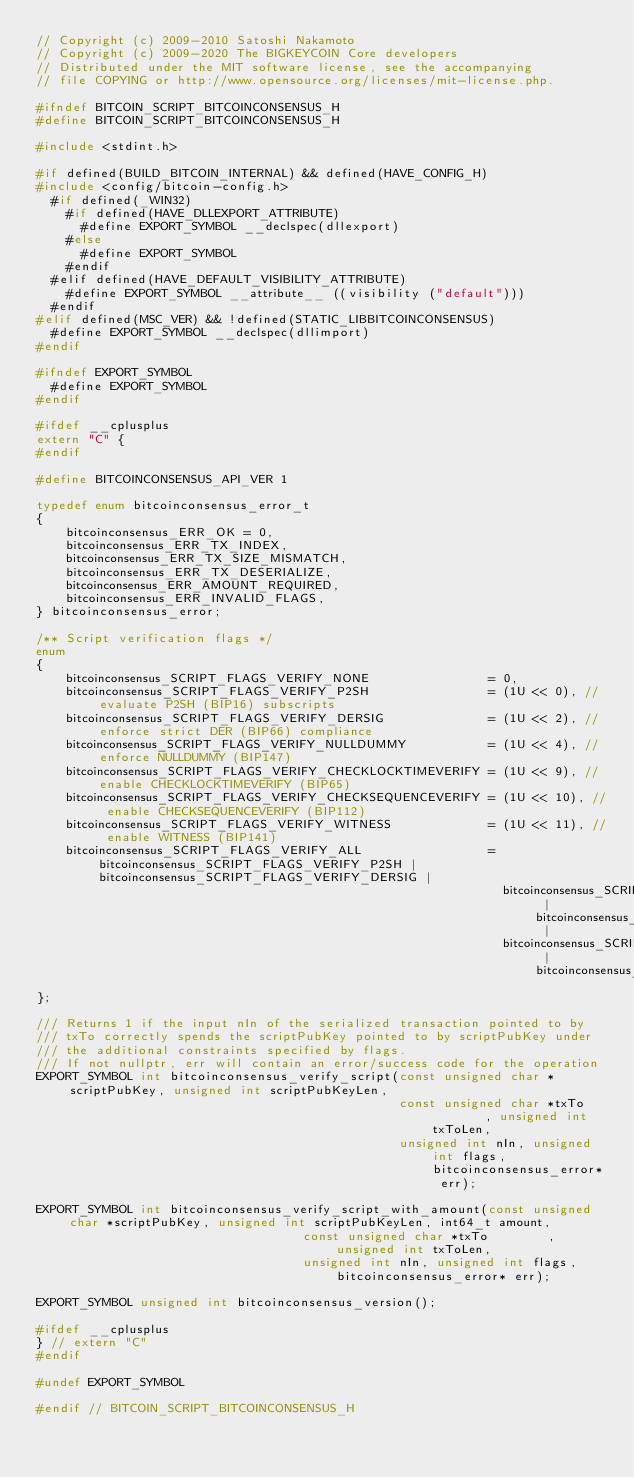<code> <loc_0><loc_0><loc_500><loc_500><_C_>// Copyright (c) 2009-2010 Satoshi Nakamoto
// Copyright (c) 2009-2020 The BIGKEYCOIN Core developers
// Distributed under the MIT software license, see the accompanying
// file COPYING or http://www.opensource.org/licenses/mit-license.php.

#ifndef BITCOIN_SCRIPT_BITCOINCONSENSUS_H
#define BITCOIN_SCRIPT_BITCOINCONSENSUS_H

#include <stdint.h>

#if defined(BUILD_BITCOIN_INTERNAL) && defined(HAVE_CONFIG_H)
#include <config/bitcoin-config.h>
  #if defined(_WIN32)
    #if defined(HAVE_DLLEXPORT_ATTRIBUTE)
      #define EXPORT_SYMBOL __declspec(dllexport)
    #else
      #define EXPORT_SYMBOL
    #endif
  #elif defined(HAVE_DEFAULT_VISIBILITY_ATTRIBUTE)
    #define EXPORT_SYMBOL __attribute__ ((visibility ("default")))
  #endif
#elif defined(MSC_VER) && !defined(STATIC_LIBBITCOINCONSENSUS)
  #define EXPORT_SYMBOL __declspec(dllimport)
#endif

#ifndef EXPORT_SYMBOL
  #define EXPORT_SYMBOL
#endif

#ifdef __cplusplus
extern "C" {
#endif

#define BITCOINCONSENSUS_API_VER 1

typedef enum bitcoinconsensus_error_t
{
    bitcoinconsensus_ERR_OK = 0,
    bitcoinconsensus_ERR_TX_INDEX,
    bitcoinconsensus_ERR_TX_SIZE_MISMATCH,
    bitcoinconsensus_ERR_TX_DESERIALIZE,
    bitcoinconsensus_ERR_AMOUNT_REQUIRED,
    bitcoinconsensus_ERR_INVALID_FLAGS,
} bitcoinconsensus_error;

/** Script verification flags */
enum
{
    bitcoinconsensus_SCRIPT_FLAGS_VERIFY_NONE                = 0,
    bitcoinconsensus_SCRIPT_FLAGS_VERIFY_P2SH                = (1U << 0), // evaluate P2SH (BIP16) subscripts
    bitcoinconsensus_SCRIPT_FLAGS_VERIFY_DERSIG              = (1U << 2), // enforce strict DER (BIP66) compliance
    bitcoinconsensus_SCRIPT_FLAGS_VERIFY_NULLDUMMY           = (1U << 4), // enforce NULLDUMMY (BIP147)
    bitcoinconsensus_SCRIPT_FLAGS_VERIFY_CHECKLOCKTIMEVERIFY = (1U << 9), // enable CHECKLOCKTIMEVERIFY (BIP65)
    bitcoinconsensus_SCRIPT_FLAGS_VERIFY_CHECKSEQUENCEVERIFY = (1U << 10), // enable CHECKSEQUENCEVERIFY (BIP112)
    bitcoinconsensus_SCRIPT_FLAGS_VERIFY_WITNESS             = (1U << 11), // enable WITNESS (BIP141)
    bitcoinconsensus_SCRIPT_FLAGS_VERIFY_ALL                 = bitcoinconsensus_SCRIPT_FLAGS_VERIFY_P2SH | bitcoinconsensus_SCRIPT_FLAGS_VERIFY_DERSIG |
                                                               bitcoinconsensus_SCRIPT_FLAGS_VERIFY_NULLDUMMY | bitcoinconsensus_SCRIPT_FLAGS_VERIFY_CHECKLOCKTIMEVERIFY |
                                                               bitcoinconsensus_SCRIPT_FLAGS_VERIFY_CHECKSEQUENCEVERIFY | bitcoinconsensus_SCRIPT_FLAGS_VERIFY_WITNESS
};

/// Returns 1 if the input nIn of the serialized transaction pointed to by
/// txTo correctly spends the scriptPubKey pointed to by scriptPubKey under
/// the additional constraints specified by flags.
/// If not nullptr, err will contain an error/success code for the operation
EXPORT_SYMBOL int bitcoinconsensus_verify_script(const unsigned char *scriptPubKey, unsigned int scriptPubKeyLen,
                                                 const unsigned char *txTo        , unsigned int txToLen,
                                                 unsigned int nIn, unsigned int flags, bitcoinconsensus_error* err);

EXPORT_SYMBOL int bitcoinconsensus_verify_script_with_amount(const unsigned char *scriptPubKey, unsigned int scriptPubKeyLen, int64_t amount,
                                    const unsigned char *txTo        , unsigned int txToLen,
                                    unsigned int nIn, unsigned int flags, bitcoinconsensus_error* err);

EXPORT_SYMBOL unsigned int bitcoinconsensus_version();

#ifdef __cplusplus
} // extern "C"
#endif

#undef EXPORT_SYMBOL

#endif // BITCOIN_SCRIPT_BITCOINCONSENSUS_H
</code> 